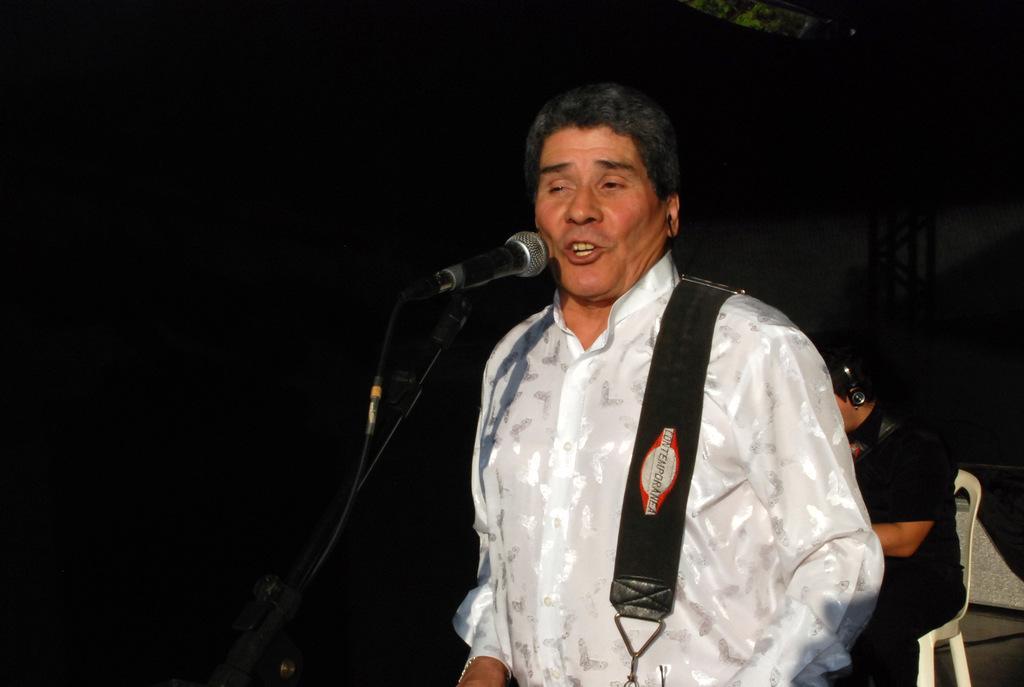How would you summarize this image in a sentence or two? In this picture we can see a person,here we can see a mic,at back of him we can see a person sitting on a chair and in the background we can see it is dark. 